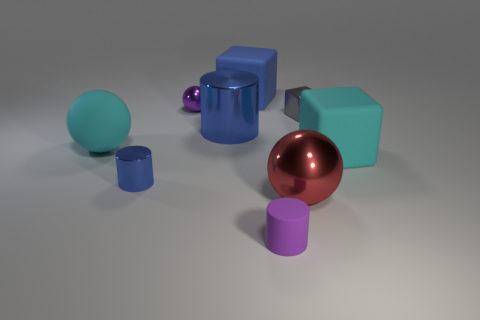Add 9 big cyan rubber cubes. How many big cyan rubber cubes exist? 10 Subtract 0 green spheres. How many objects are left? 9 Subtract all spheres. How many objects are left? 6 Subtract all cyan objects. Subtract all blue shiny things. How many objects are left? 5 Add 5 big blocks. How many big blocks are left? 7 